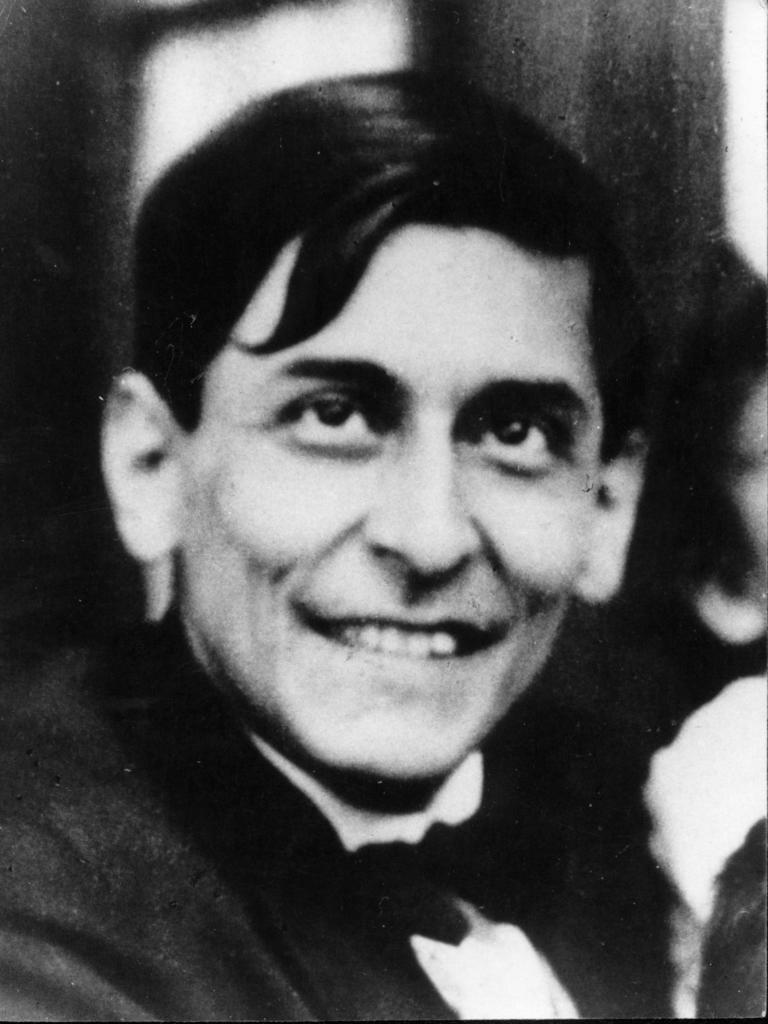What is the color scheme of the image? The image is black and white. Who is present in the image? There is a man in the image. What is the man doing in the image? The man is smiling. What type of music can be heard playing in the background of the image? There is no music or sound present in the image, as it is a still photograph. 